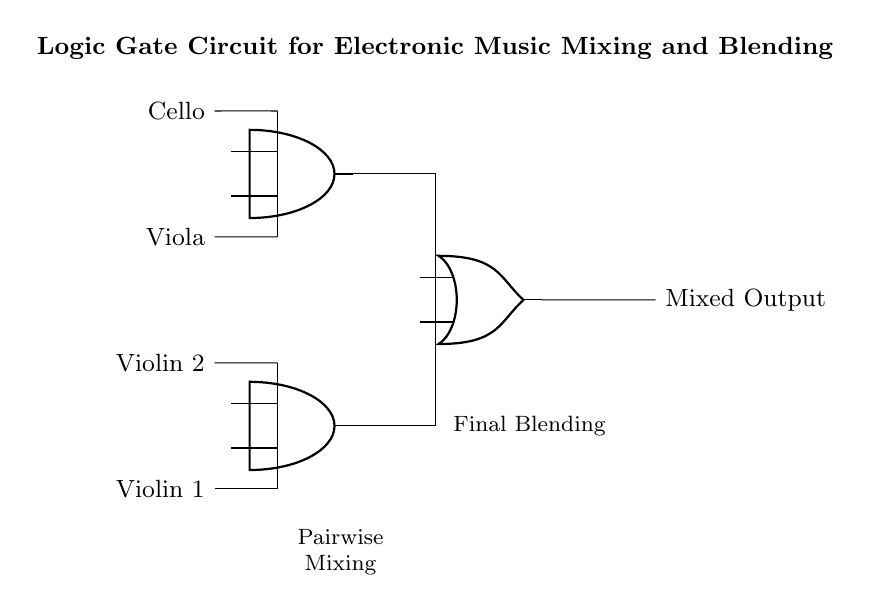What instruments are used as inputs in this circuit? The circuit shows input signals from four instruments: Violin 1, Violin 2, Viola, and Cello. Each instrument is connected to the circuit, indicating they serve as audio input sources for mixing.
Answer: Violin 1, Violin 2, Viola, Cello What type of gates are used in this music mixing circuit? The circuit features AND gates for pairwise mixing of the inputs and an OR gate for the final mixing. The AND gates perform logic operations on pairs of inputs, while the OR gate combines the outputs of the AND gates.
Answer: AND and OR gates How many AND gates are present in the circuit? The circuit contains two AND gates, each responsible for mixing two instruments. The first mixes Violin 1 and Violin 2, and the second mixes Viola and Cello.
Answer: Two What is the purpose of the OR gate in this circuit? The OR gate combines the outputs of the two AND gates, allowing the mixed signals from both pairs of instruments to be blended together into a single mixed output. This final blending step is crucial for achieving the desired audio output.
Answer: Final blending Which instruments are mixed by the first AND gate? The first AND gate combines the signals from Violin 1 and Violin 2, as indicated by their connections to the inputs of that gate. This means these two violins share the same outcome through their pairing in the mixing process.
Answer: Violin 1 and Violin 2 What does the output represent in this circuit? The output represents the mixed audio signal that results from the combination of the individual inputs processed by the AND and OR gates. This mixed output can be considered the final sound that incorporates elements from all four instruments.
Answer: Mixed Output 